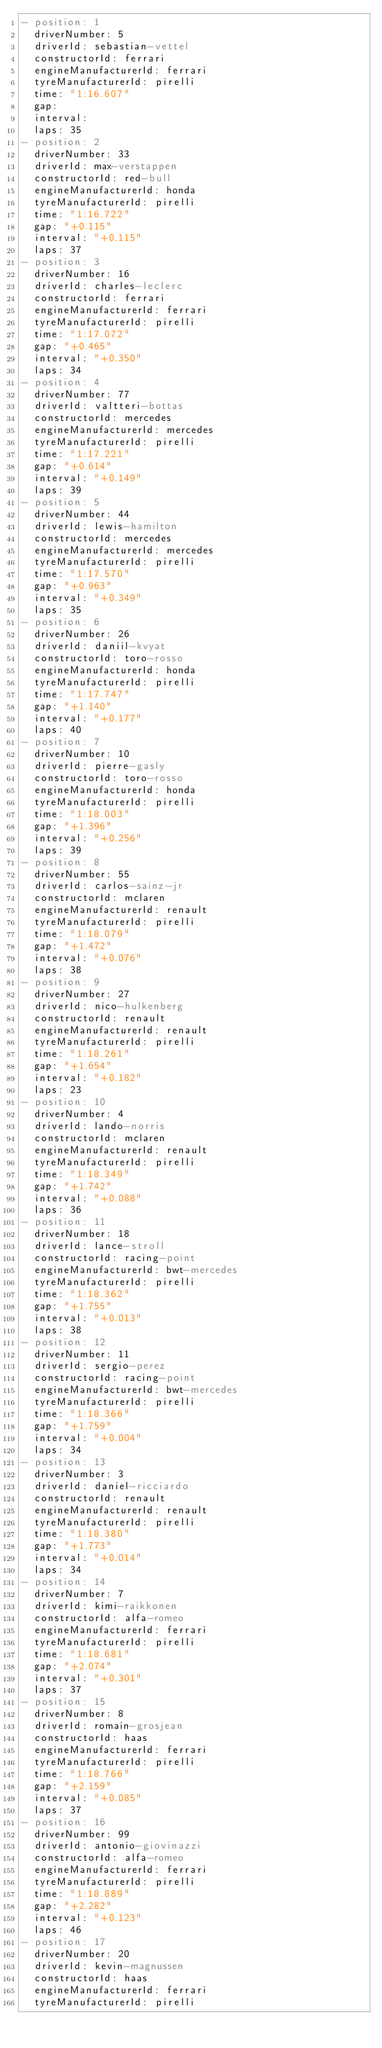<code> <loc_0><loc_0><loc_500><loc_500><_YAML_>- position: 1
  driverNumber: 5
  driverId: sebastian-vettel
  constructorId: ferrari
  engineManufacturerId: ferrari
  tyreManufacturerId: pirelli
  time: "1:16.607"
  gap:
  interval:
  laps: 35
- position: 2
  driverNumber: 33
  driverId: max-verstappen
  constructorId: red-bull
  engineManufacturerId: honda
  tyreManufacturerId: pirelli
  time: "1:16.722"
  gap: "+0.115"
  interval: "+0.115"
  laps: 37
- position: 3
  driverNumber: 16
  driverId: charles-leclerc
  constructorId: ferrari
  engineManufacturerId: ferrari
  tyreManufacturerId: pirelli
  time: "1:17.072"
  gap: "+0.465"
  interval: "+0.350"
  laps: 34
- position: 4
  driverNumber: 77
  driverId: valtteri-bottas
  constructorId: mercedes
  engineManufacturerId: mercedes
  tyreManufacturerId: pirelli
  time: "1:17.221"
  gap: "+0.614"
  interval: "+0.149"
  laps: 39
- position: 5
  driverNumber: 44
  driverId: lewis-hamilton
  constructorId: mercedes
  engineManufacturerId: mercedes
  tyreManufacturerId: pirelli
  time: "1:17.570"
  gap: "+0.963"
  interval: "+0.349"
  laps: 35
- position: 6
  driverNumber: 26
  driverId: daniil-kvyat
  constructorId: toro-rosso
  engineManufacturerId: honda
  tyreManufacturerId: pirelli
  time: "1:17.747"
  gap: "+1.140"
  interval: "+0.177"
  laps: 40
- position: 7
  driverNumber: 10
  driverId: pierre-gasly
  constructorId: toro-rosso
  engineManufacturerId: honda
  tyreManufacturerId: pirelli
  time: "1:18.003"
  gap: "+1.396"
  interval: "+0.256"
  laps: 39
- position: 8
  driverNumber: 55
  driverId: carlos-sainz-jr
  constructorId: mclaren
  engineManufacturerId: renault
  tyreManufacturerId: pirelli
  time: "1:18.079"
  gap: "+1.472"
  interval: "+0.076"
  laps: 38
- position: 9
  driverNumber: 27
  driverId: nico-hulkenberg
  constructorId: renault
  engineManufacturerId: renault
  tyreManufacturerId: pirelli
  time: "1:18.261"
  gap: "+1.654"
  interval: "+0.182"
  laps: 23
- position: 10
  driverNumber: 4
  driverId: lando-norris
  constructorId: mclaren
  engineManufacturerId: renault
  tyreManufacturerId: pirelli
  time: "1:18.349"
  gap: "+1.742"
  interval: "+0.088"
  laps: 36
- position: 11
  driverNumber: 18
  driverId: lance-stroll
  constructorId: racing-point
  engineManufacturerId: bwt-mercedes
  tyreManufacturerId: pirelli
  time: "1:18.362"
  gap: "+1.755"
  interval: "+0.013"
  laps: 38
- position: 12
  driverNumber: 11
  driverId: sergio-perez
  constructorId: racing-point
  engineManufacturerId: bwt-mercedes
  tyreManufacturerId: pirelli
  time: "1:18.366"
  gap: "+1.759"
  interval: "+0.004"
  laps: 34
- position: 13
  driverNumber: 3
  driverId: daniel-ricciardo
  constructorId: renault
  engineManufacturerId: renault
  tyreManufacturerId: pirelli
  time: "1:18.380"
  gap: "+1.773"
  interval: "+0.014"
  laps: 34
- position: 14
  driverNumber: 7
  driverId: kimi-raikkonen
  constructorId: alfa-romeo
  engineManufacturerId: ferrari
  tyreManufacturerId: pirelli
  time: "1:18.681"
  gap: "+2.074"
  interval: "+0.301"
  laps: 37
- position: 15
  driverNumber: 8
  driverId: romain-grosjean
  constructorId: haas
  engineManufacturerId: ferrari
  tyreManufacturerId: pirelli
  time: "1:18.766"
  gap: "+2.159"
  interval: "+0.085"
  laps: 37
- position: 16
  driverNumber: 99
  driverId: antonio-giovinazzi
  constructorId: alfa-romeo
  engineManufacturerId: ferrari
  tyreManufacturerId: pirelli
  time: "1:18.889"
  gap: "+2.282"
  interval: "+0.123"
  laps: 46
- position: 17
  driverNumber: 20
  driverId: kevin-magnussen
  constructorId: haas
  engineManufacturerId: ferrari
  tyreManufacturerId: pirelli</code> 